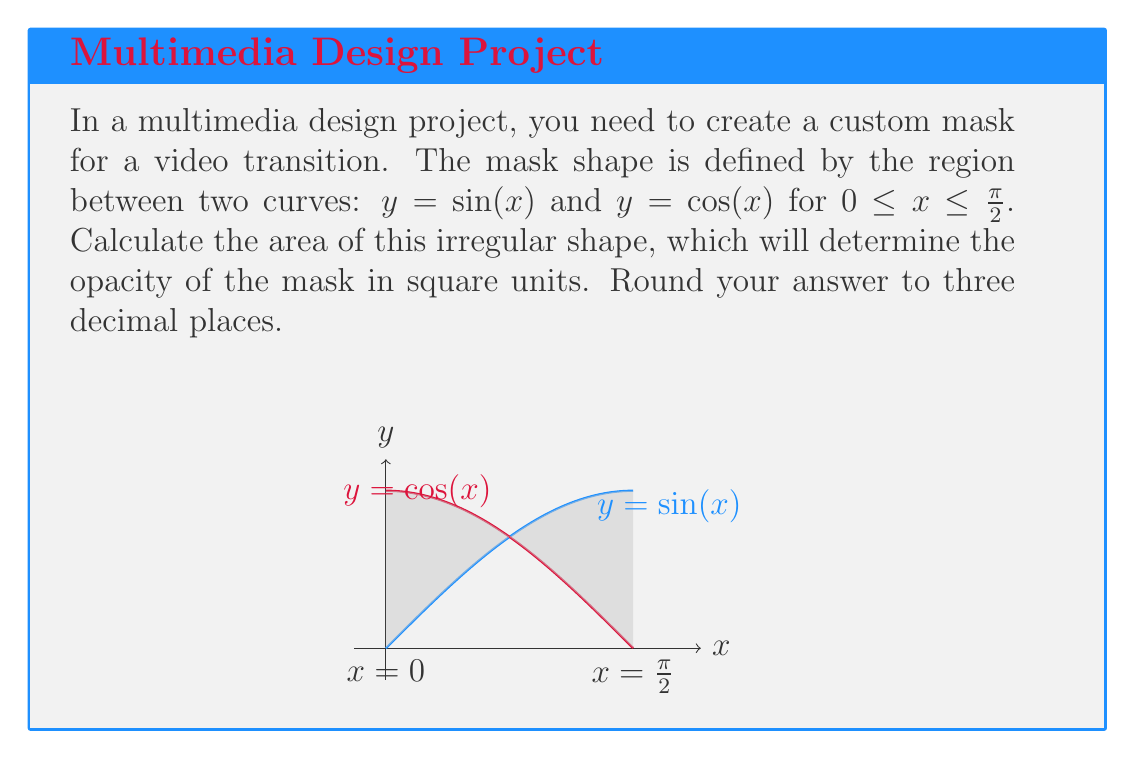Can you solve this math problem? To find the area of the region between two curves, we need to integrate the difference between the upper and lower functions over the given interval. In this case:

1) The upper function is $y = \sin(x)$
2) The lower function is $y = \cos(x)$
3) The interval is $[0, \frac{\pi}{2}]$

The formula for the area is:

$$A = \int_{a}^{b} [f(x) - g(x)] dx$$

Where $f(x)$ is the upper function and $g(x)$ is the lower function.

Substituting our functions:

$$A = \int_{0}^{\frac{\pi}{2}} [\sin(x) - \cos(x)] dx$$

To solve this integral, we can use the antiderivatives of sine and cosine:

$$A = [-\cos(x) - \sin(x)]_{0}^{\frac{\pi}{2}}$$

Now, let's evaluate the integral:

$$A = [-\cos(\frac{\pi}{2}) - \sin(\frac{\pi}{2})] - [-\cos(0) - \sin(0)]$$

$$A = [0 - 1] - [-1 - 0]$$

$$A = -1 - (-1)$$

$$A = -1 + 1 = 0$$

Therefore, the area of the region between the curves is 0 square units.

This result might seem counterintuitive, but it's correct. The areas above and below the intersection point of the two curves cancel each other out, resulting in a net area of zero.
Answer: 0.000 square units 